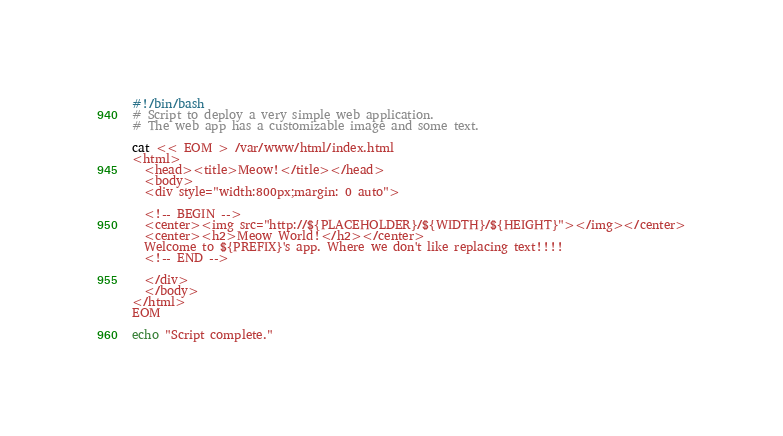<code> <loc_0><loc_0><loc_500><loc_500><_Bash_>#!/bin/bash
# Script to deploy a very simple web application.
# The web app has a customizable image and some text.

cat << EOM > /var/www/html/index.html
<html>
  <head><title>Meow!</title></head>
  <body>
  <div style="width:800px;margin: 0 auto">

  <!-- BEGIN -->
  <center><img src="http://${PLACEHOLDER}/${WIDTH}/${HEIGHT}"></img></center>
  <center><h2>Meow World!</h2></center>
  Welcome to ${PREFIX}'s app. Where we don't like replacing text!!!! 
  <!-- END -->
  
  </div>
  </body>
</html>
EOM

echo "Script complete."
</code> 